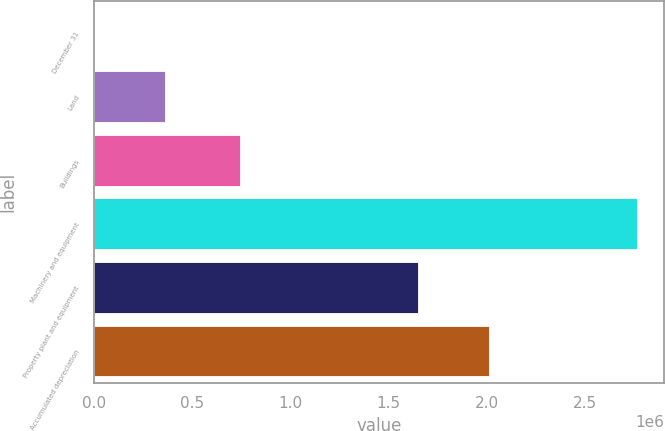Convert chart. <chart><loc_0><loc_0><loc_500><loc_500><bar_chart><fcel>December 31<fcel>Land<fcel>Buildings<fcel>Machinery and equipment<fcel>Property plant and equipment<fcel>Accumulated depreciation<nl><fcel>2006<fcel>361581<fcel>746198<fcel>2.76482e+06<fcel>1.6513e+06<fcel>2.01088e+06<nl></chart> 